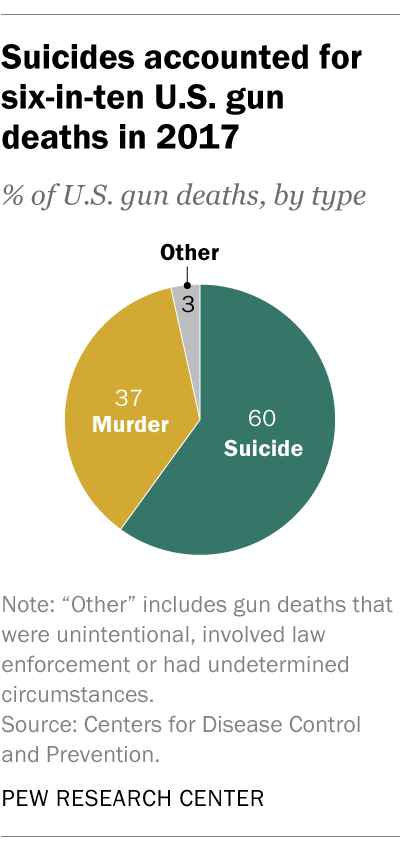Specify some key components in this picture. The ratio of U.S. gun deaths from murder to suicide in 2017 was 0.6167, meaning that approximately 62% of all gun deaths that year were intentional self-harm. In 2017, approximately 37% of gun deaths in the United States were due to murder. 